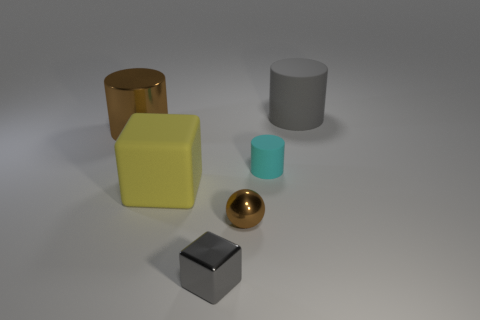Subtract all purple cubes. Subtract all blue balls. How many cubes are left? 2 Add 1 gray metallic cubes. How many objects exist? 7 Subtract all blocks. How many objects are left? 4 Add 1 gray metal objects. How many gray metal objects exist? 2 Subtract 0 red cubes. How many objects are left? 6 Subtract all large shiny cylinders. Subtract all yellow things. How many objects are left? 4 Add 1 small cylinders. How many small cylinders are left? 2 